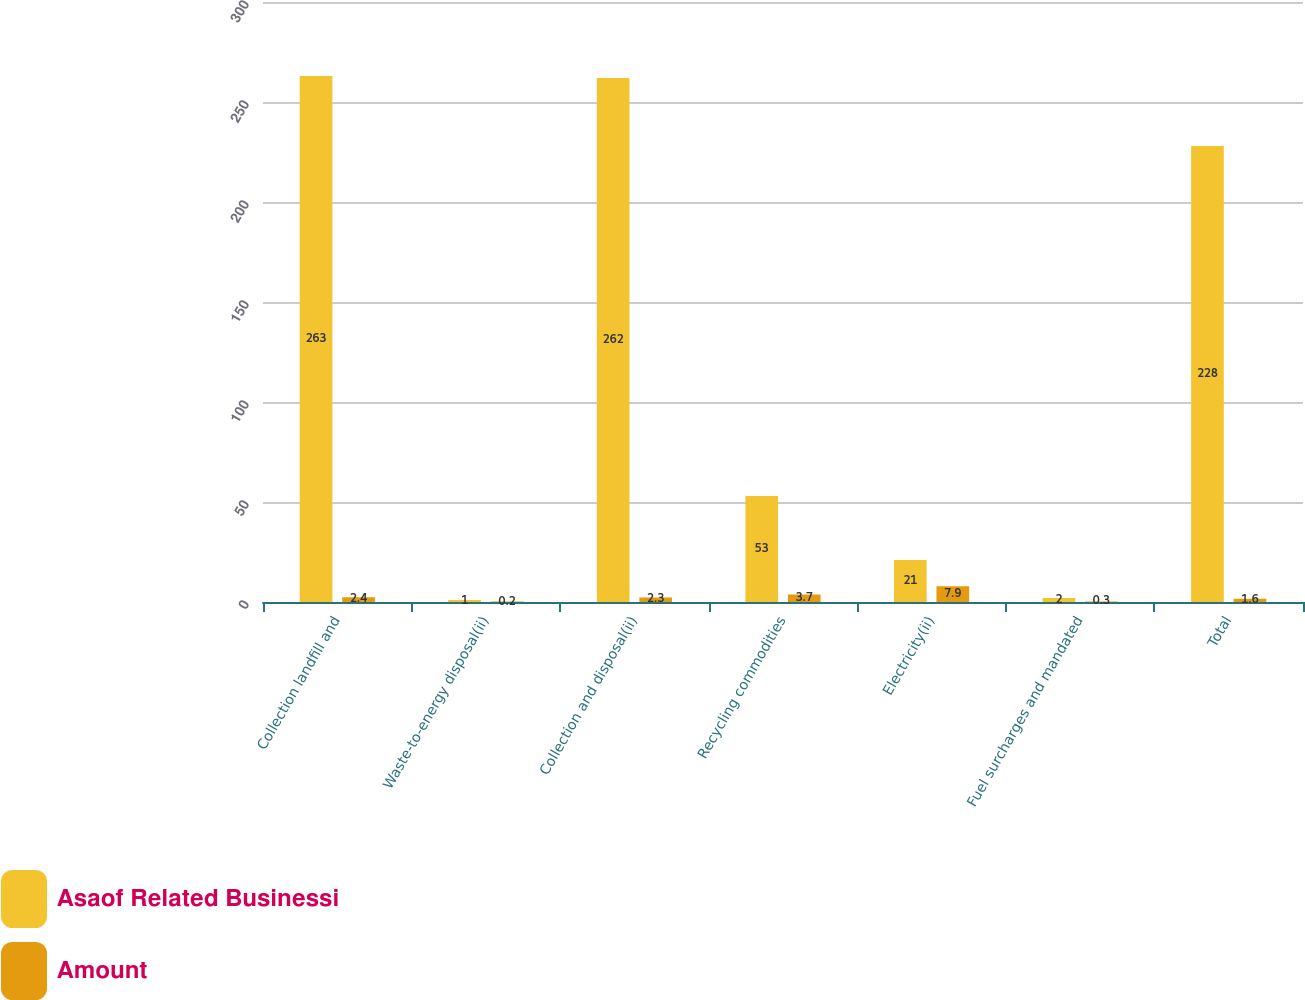<chart> <loc_0><loc_0><loc_500><loc_500><stacked_bar_chart><ecel><fcel>Collection landfill and<fcel>Waste-to-energy disposal(ii)<fcel>Collection and disposal(ii)<fcel>Recycling commodities<fcel>Electricity(ii)<fcel>Fuel surcharges and mandated<fcel>Total<nl><fcel>Asaof Related Businessi<fcel>263<fcel>1<fcel>262<fcel>53<fcel>21<fcel>2<fcel>228<nl><fcel>Amount<fcel>2.4<fcel>0.2<fcel>2.3<fcel>3.7<fcel>7.9<fcel>0.3<fcel>1.6<nl></chart> 